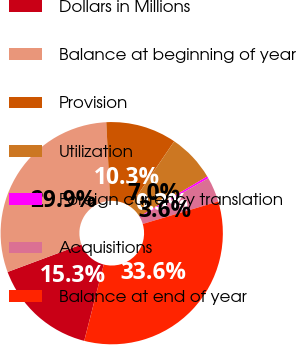<chart> <loc_0><loc_0><loc_500><loc_500><pie_chart><fcel>Dollars in Millions<fcel>Balance at beginning of year<fcel>Provision<fcel>Utilization<fcel>Foreign currency translation<fcel>Acquisitions<fcel>Balance at end of year<nl><fcel>15.35%<fcel>29.9%<fcel>10.29%<fcel>6.96%<fcel>0.3%<fcel>3.63%<fcel>33.59%<nl></chart> 